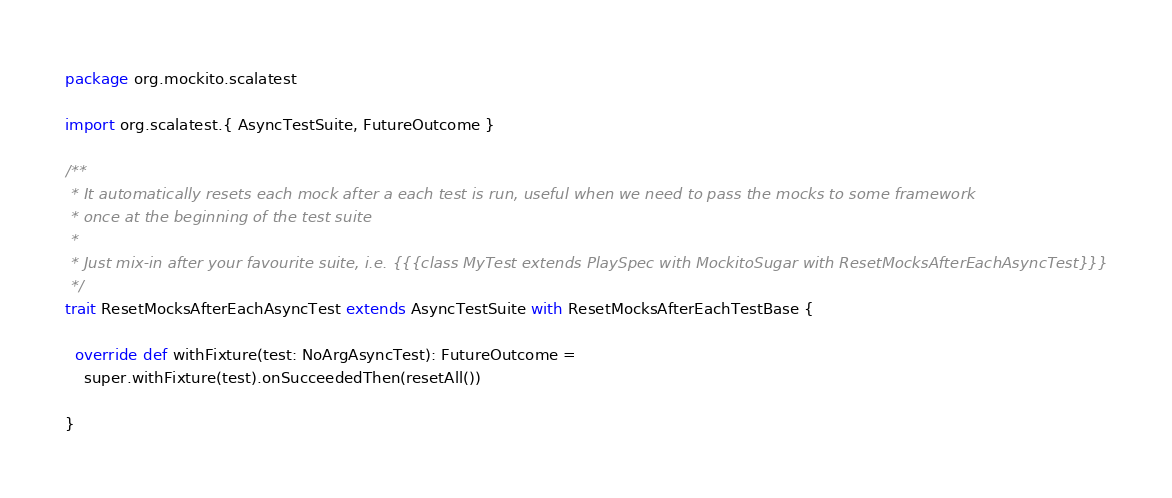Convert code to text. <code><loc_0><loc_0><loc_500><loc_500><_Scala_>package org.mockito.scalatest

import org.scalatest.{ AsyncTestSuite, FutureOutcome }

/**
 * It automatically resets each mock after a each test is run, useful when we need to pass the mocks to some framework
 * once at the beginning of the test suite
 *
 * Just mix-in after your favourite suite, i.e. {{{class MyTest extends PlaySpec with MockitoSugar with ResetMocksAfterEachAsyncTest}}}
 */
trait ResetMocksAfterEachAsyncTest extends AsyncTestSuite with ResetMocksAfterEachTestBase {

  override def withFixture(test: NoArgAsyncTest): FutureOutcome =
    super.withFixture(test).onSucceededThen(resetAll())

}
</code> 